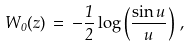Convert formula to latex. <formula><loc_0><loc_0><loc_500><loc_500>W _ { 0 } ( z ) \, = \, - \frac { 1 } { 2 } \log \left ( \frac { \sin u } { u } \right ) \, ,</formula> 